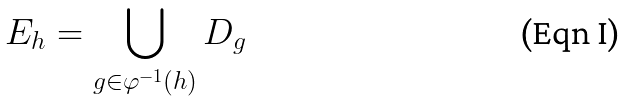Convert formula to latex. <formula><loc_0><loc_0><loc_500><loc_500>E _ { h } = \bigcup _ { g \in \varphi ^ { - 1 } ( h ) } D _ { g }</formula> 